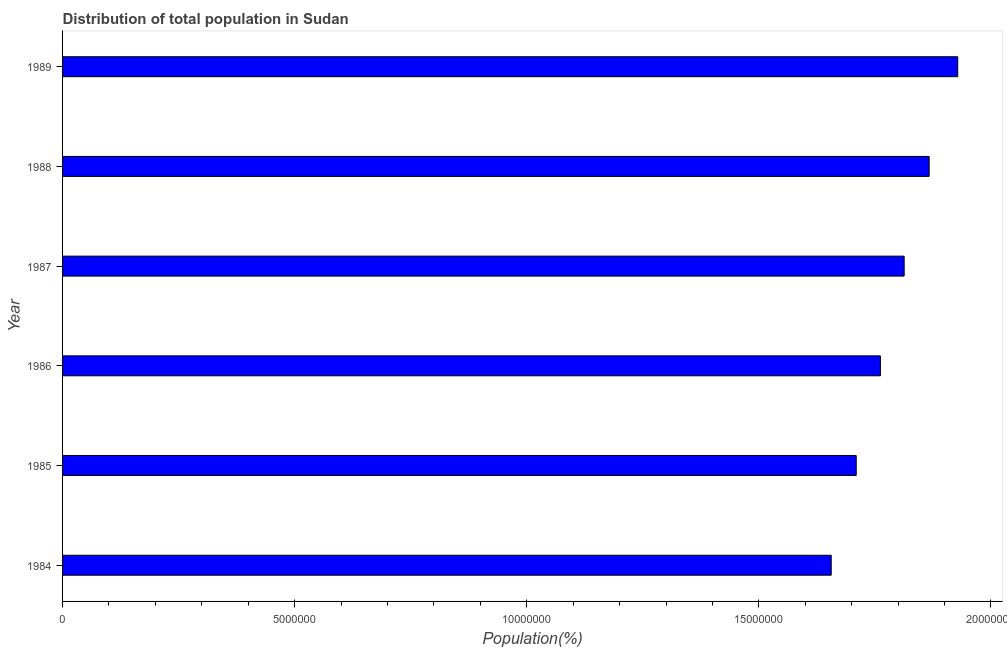Does the graph contain any zero values?
Your response must be concise. No. What is the title of the graph?
Ensure brevity in your answer.  Distribution of total population in Sudan . What is the label or title of the X-axis?
Provide a succinct answer. Population(%). What is the population in 1989?
Give a very brief answer. 1.93e+07. Across all years, what is the maximum population?
Provide a succinct answer. 1.93e+07. Across all years, what is the minimum population?
Your answer should be compact. 1.66e+07. In which year was the population maximum?
Provide a succinct answer. 1989. What is the sum of the population?
Offer a terse response. 1.07e+08. What is the difference between the population in 1986 and 1987?
Give a very brief answer. -5.12e+05. What is the average population per year?
Keep it short and to the point. 1.79e+07. What is the median population?
Keep it short and to the point. 1.79e+07. In how many years, is the population greater than 12000000 %?
Offer a terse response. 6. Do a majority of the years between 1986 and 1987 (inclusive) have population greater than 6000000 %?
Ensure brevity in your answer.  Yes. What is the ratio of the population in 1987 to that in 1989?
Provide a short and direct response. 0.94. Is the difference between the population in 1987 and 1989 greater than the difference between any two years?
Offer a terse response. No. What is the difference between the highest and the second highest population?
Provide a short and direct response. 6.15e+05. Is the sum of the population in 1987 and 1988 greater than the maximum population across all years?
Your answer should be very brief. Yes. What is the difference between the highest and the lowest population?
Your response must be concise. 2.73e+06. How many years are there in the graph?
Your response must be concise. 6. What is the Population(%) in 1984?
Offer a terse response. 1.66e+07. What is the Population(%) in 1985?
Offer a terse response. 1.71e+07. What is the Population(%) in 1986?
Your answer should be very brief. 1.76e+07. What is the Population(%) in 1987?
Provide a short and direct response. 1.81e+07. What is the Population(%) in 1988?
Your response must be concise. 1.87e+07. What is the Population(%) in 1989?
Make the answer very short. 1.93e+07. What is the difference between the Population(%) in 1984 and 1985?
Give a very brief answer. -5.38e+05. What is the difference between the Population(%) in 1984 and 1986?
Make the answer very short. -1.06e+06. What is the difference between the Population(%) in 1984 and 1987?
Your answer should be very brief. -1.57e+06. What is the difference between the Population(%) in 1984 and 1988?
Your response must be concise. -2.11e+06. What is the difference between the Population(%) in 1984 and 1989?
Make the answer very short. -2.73e+06. What is the difference between the Population(%) in 1985 and 1986?
Provide a short and direct response. -5.21e+05. What is the difference between the Population(%) in 1985 and 1987?
Give a very brief answer. -1.03e+06. What is the difference between the Population(%) in 1985 and 1988?
Ensure brevity in your answer.  -1.57e+06. What is the difference between the Population(%) in 1985 and 1989?
Offer a very short reply. -2.19e+06. What is the difference between the Population(%) in 1986 and 1987?
Your answer should be very brief. -5.12e+05. What is the difference between the Population(%) in 1986 and 1988?
Provide a short and direct response. -1.05e+06. What is the difference between the Population(%) in 1986 and 1989?
Offer a very short reply. -1.67e+06. What is the difference between the Population(%) in 1987 and 1988?
Offer a terse response. -5.39e+05. What is the difference between the Population(%) in 1987 and 1989?
Ensure brevity in your answer.  -1.15e+06. What is the difference between the Population(%) in 1988 and 1989?
Offer a very short reply. -6.15e+05. What is the ratio of the Population(%) in 1984 to that in 1988?
Provide a short and direct response. 0.89. What is the ratio of the Population(%) in 1984 to that in 1989?
Provide a succinct answer. 0.86. What is the ratio of the Population(%) in 1985 to that in 1987?
Provide a succinct answer. 0.94. What is the ratio of the Population(%) in 1985 to that in 1988?
Give a very brief answer. 0.92. What is the ratio of the Population(%) in 1985 to that in 1989?
Your answer should be very brief. 0.89. What is the ratio of the Population(%) in 1986 to that in 1988?
Keep it short and to the point. 0.94. What is the ratio of the Population(%) in 1986 to that in 1989?
Your response must be concise. 0.91. What is the ratio of the Population(%) in 1987 to that in 1989?
Offer a very short reply. 0.94. What is the ratio of the Population(%) in 1988 to that in 1989?
Ensure brevity in your answer.  0.97. 